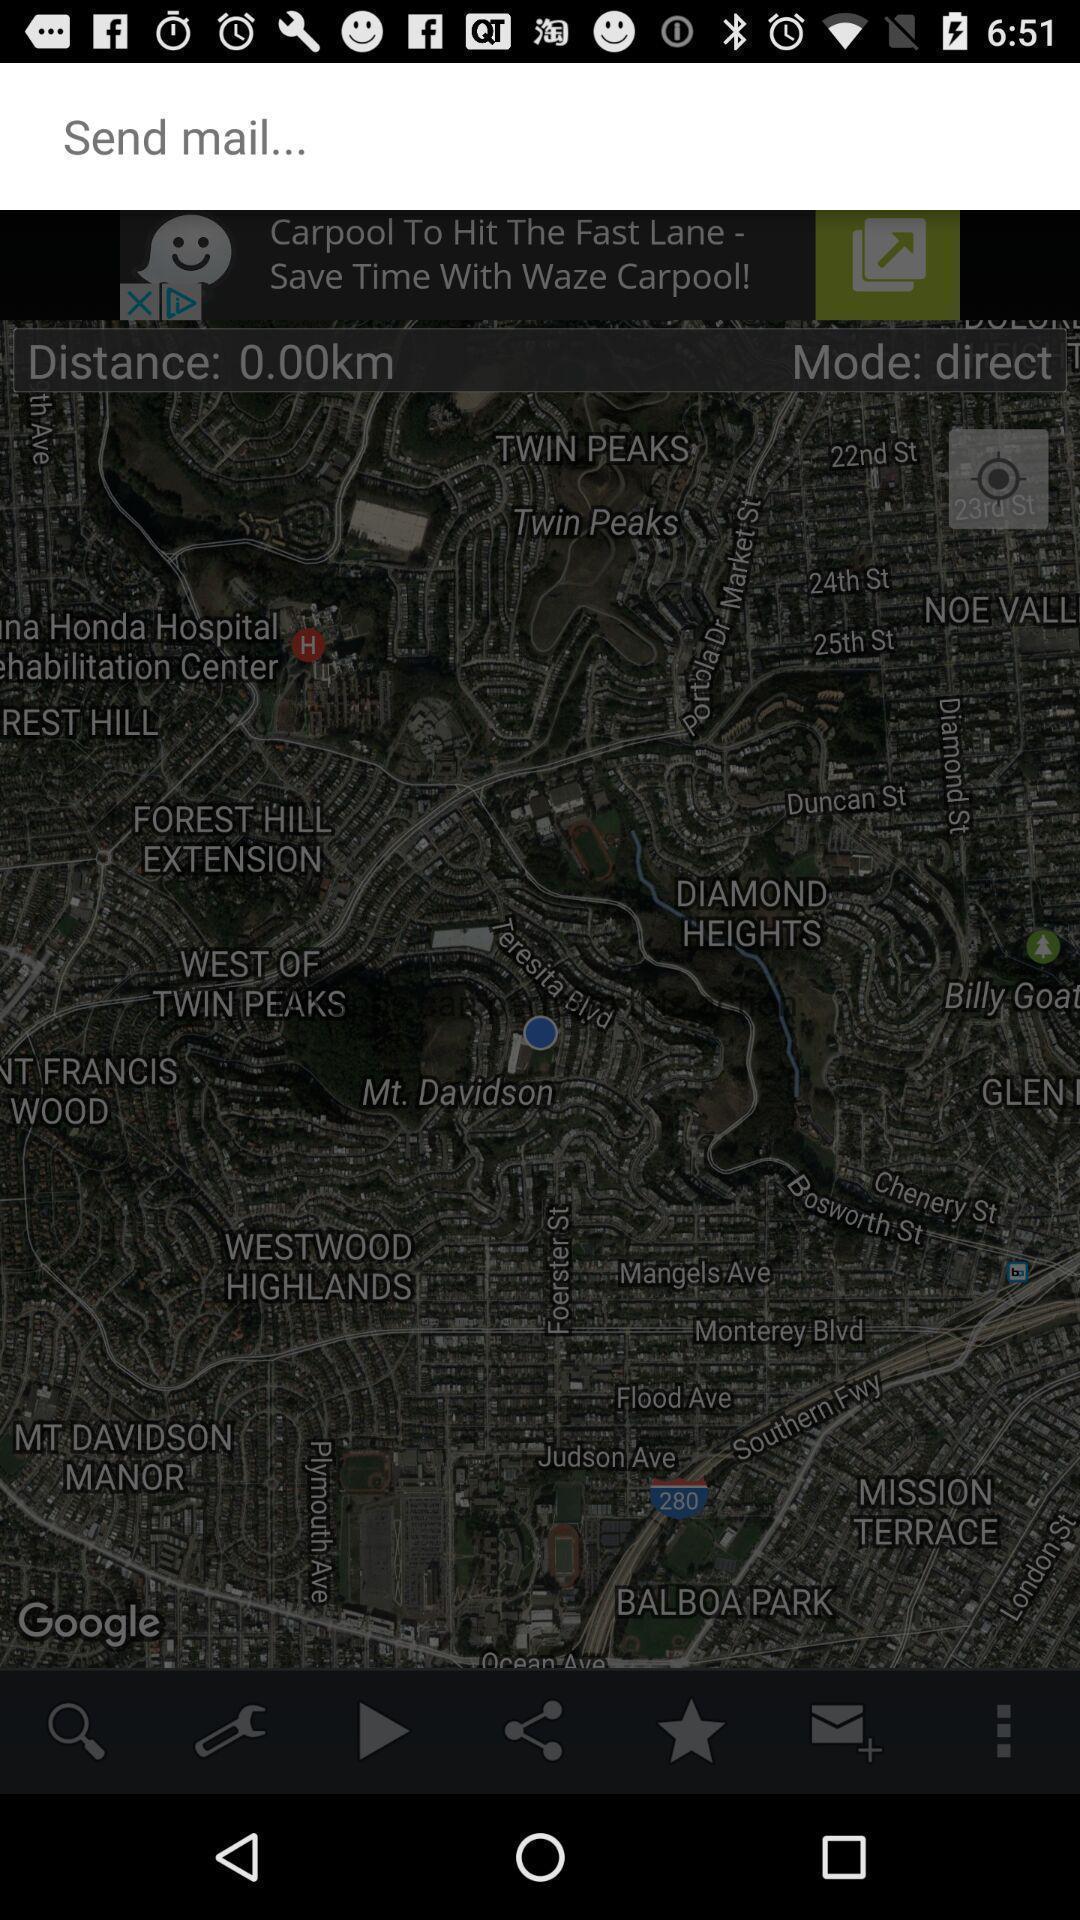Describe the content in this image. Page showing for sending your location through mail. 